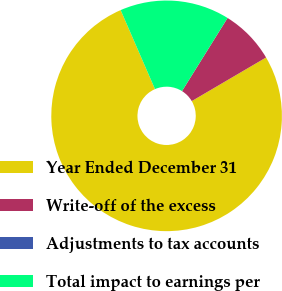Convert chart. <chart><loc_0><loc_0><loc_500><loc_500><pie_chart><fcel>Year Ended December 31<fcel>Write-off of the excess<fcel>Adjustments to tax accounts<fcel>Total impact to earnings per<nl><fcel>76.92%<fcel>7.69%<fcel>0.0%<fcel>15.39%<nl></chart> 